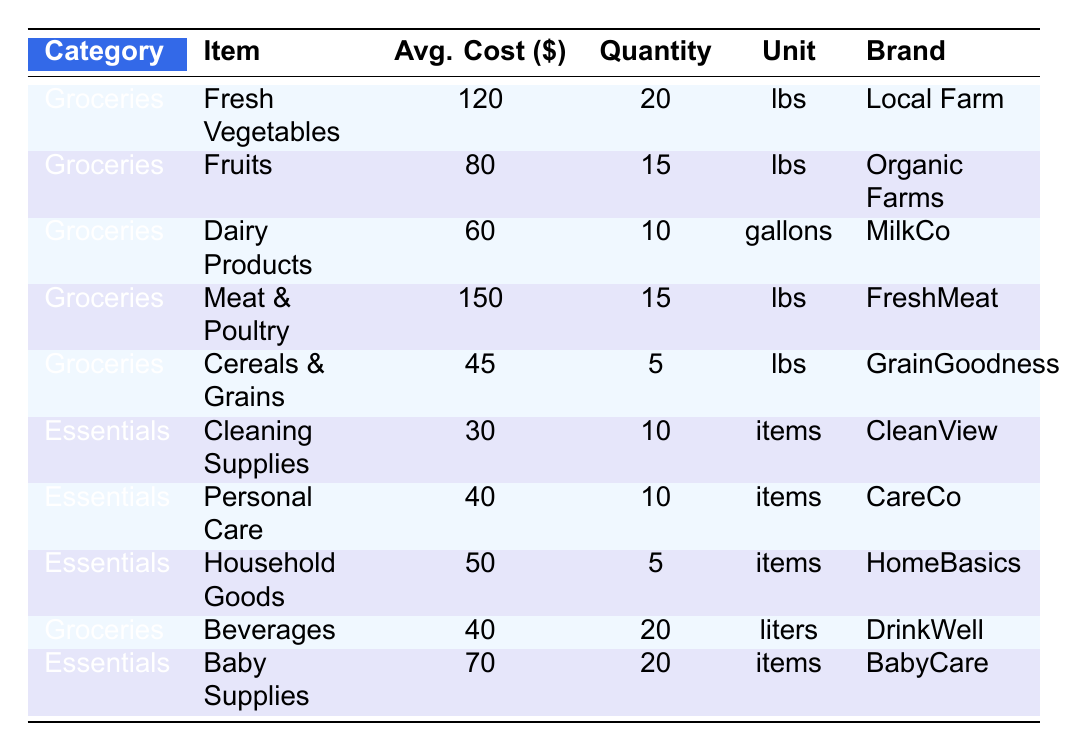What is the average cost of Fruits? The average cost of Fruits is already provided in the table as 80.
Answer: 80 Which item has the highest average cost? By reviewing the average costs listed, Meat & Poultry has the highest average cost of 150.
Answer: Meat & Poultry How much do you spend on cleaning supplies compared to personal care items? The average cost for cleaning supplies is 30, while personal care items cost 40. The difference is 40 - 30 = 10.
Answer: 10 What is the total average cost of all grocery items? The grocery items and their average costs are as follows: Fresh Vegetables (120), Fruits (80), Dairy Products (60), Meat & Poultry (150), Cereals & Grains (45), and Beverages (40). Adding these together gives a total of 495.
Answer: 495 Are there more items listed under Groceries or Essentials? There are 5 items listed under Groceries and 5 items listed under Essentials, so they are equal.
Answer: No What is the total quantity of Baby Supplies purchased? The table lists the quantity for Baby Supplies as 20. Therefore, the total quantity is 20.
Answer: 20 Calculate the average cost of Groceries. The average costs for grocery items are 120, 80, 60, 150, 45, and 40. First, add these values: 120 + 80 + 60 + 150 + 45 + 40 = 495. There are 6 grocery items, so the average cost is 495 / 6 = 82.5.
Answer: 82.5 Is there a higher average quantity for cleaning supplies or personal care items? The average quantity for cleaning supplies is 10 and for personal care items, it is also 10. Since they are equal, cleaning supplies do not have a higher average quantity.
Answer: No How much is spent on Dairy Products in total? The average cost for Dairy Products is 60 and the quantity purchased is 10. Therefore, total spending is 60 * 10 = 600.
Answer: 600 